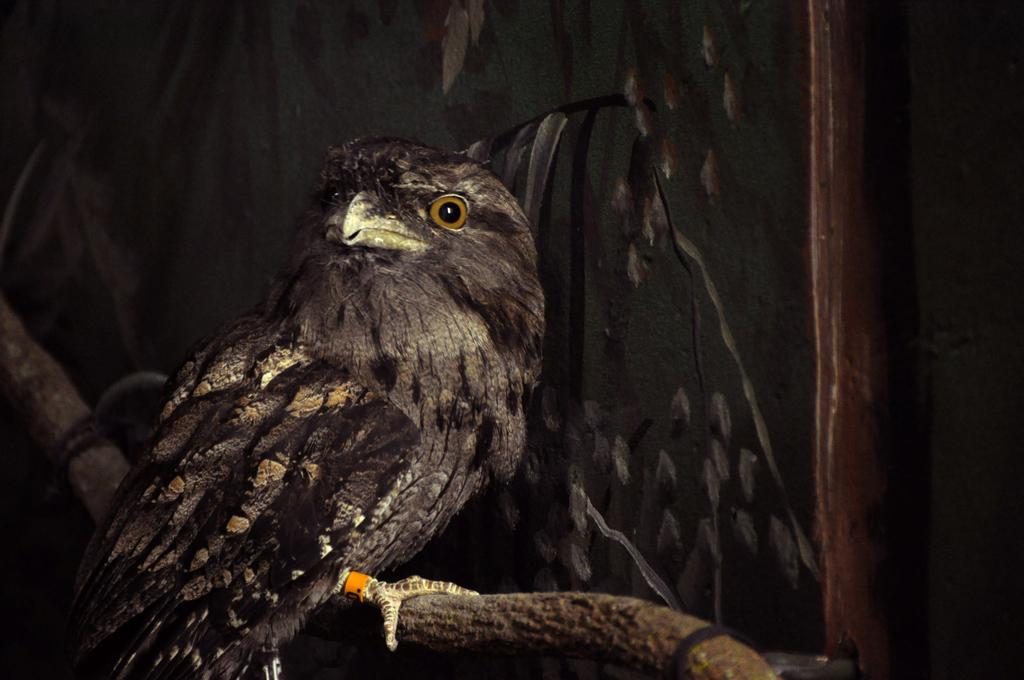What type of animal can be seen in the image? There is a bird in the image. Where is the bird located? The bird is on a stem. What is visible on the right side of the image? There is a pole on the right side of the image. What can be seen in the background of the image? There is a wall in the background of the image. How many kittens are playing with a fork in the image? There are no kittens or forks present in the image. 